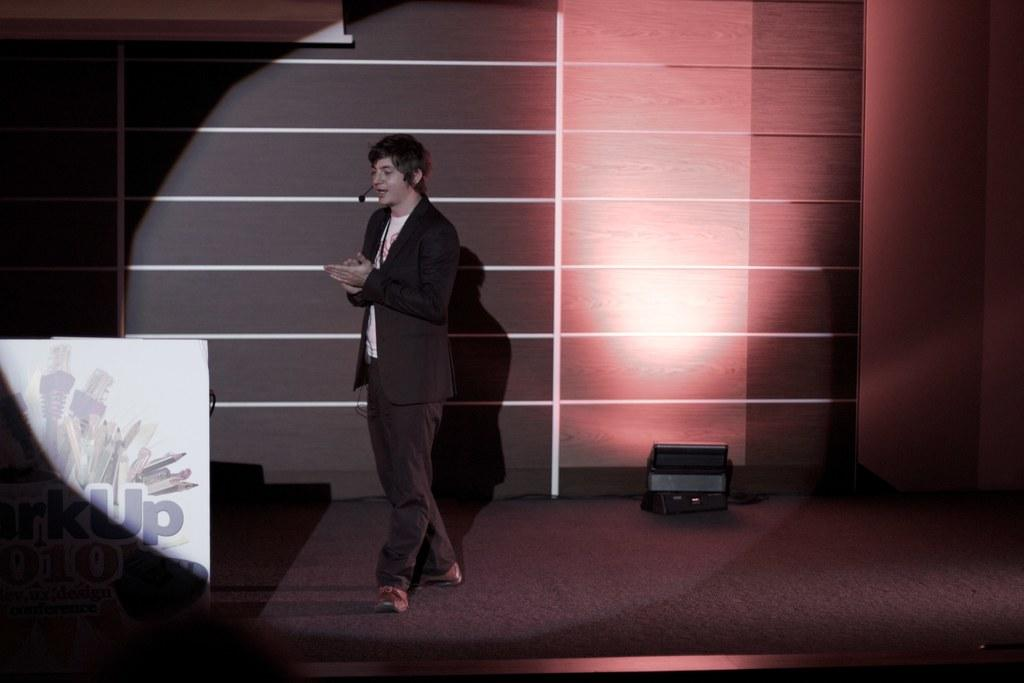What is the main subject of the image? There is a man standing in the image. What is the man wearing? The man is wearing clothes and shoes. What objects can be seen in the image related to sound? There are microphones in the image. What type of visual aid is present in the image? There is a poster in the image. What source of illumination is visible in the image? There is a light in the image. What type of surface is the man standing on? There is a floor in the image. What type of structure is visible in the image? There is a wall in the image. What type of lettuce is being used as a prop in the image? There is no lettuce present in the image. Can you hear the sound of thunder in the image? The image is a still picture, so there is no sound or thunder present. 